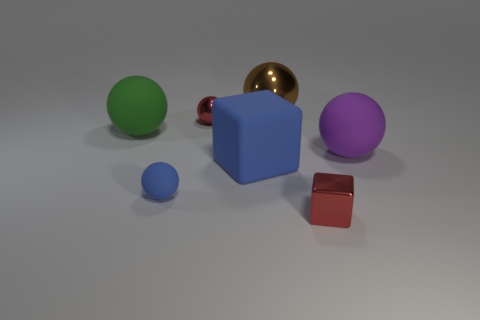Does the small thing behind the big purple ball have the same material as the tiny block? Based on the visual evidence, the small object behind the large purple sphere appears to exhibit similar reflective properties to the tiny cube, suggesting they could be made of the same or similar materials. However, without more information, it is not possible to conclusively determine this just by looking at them. 